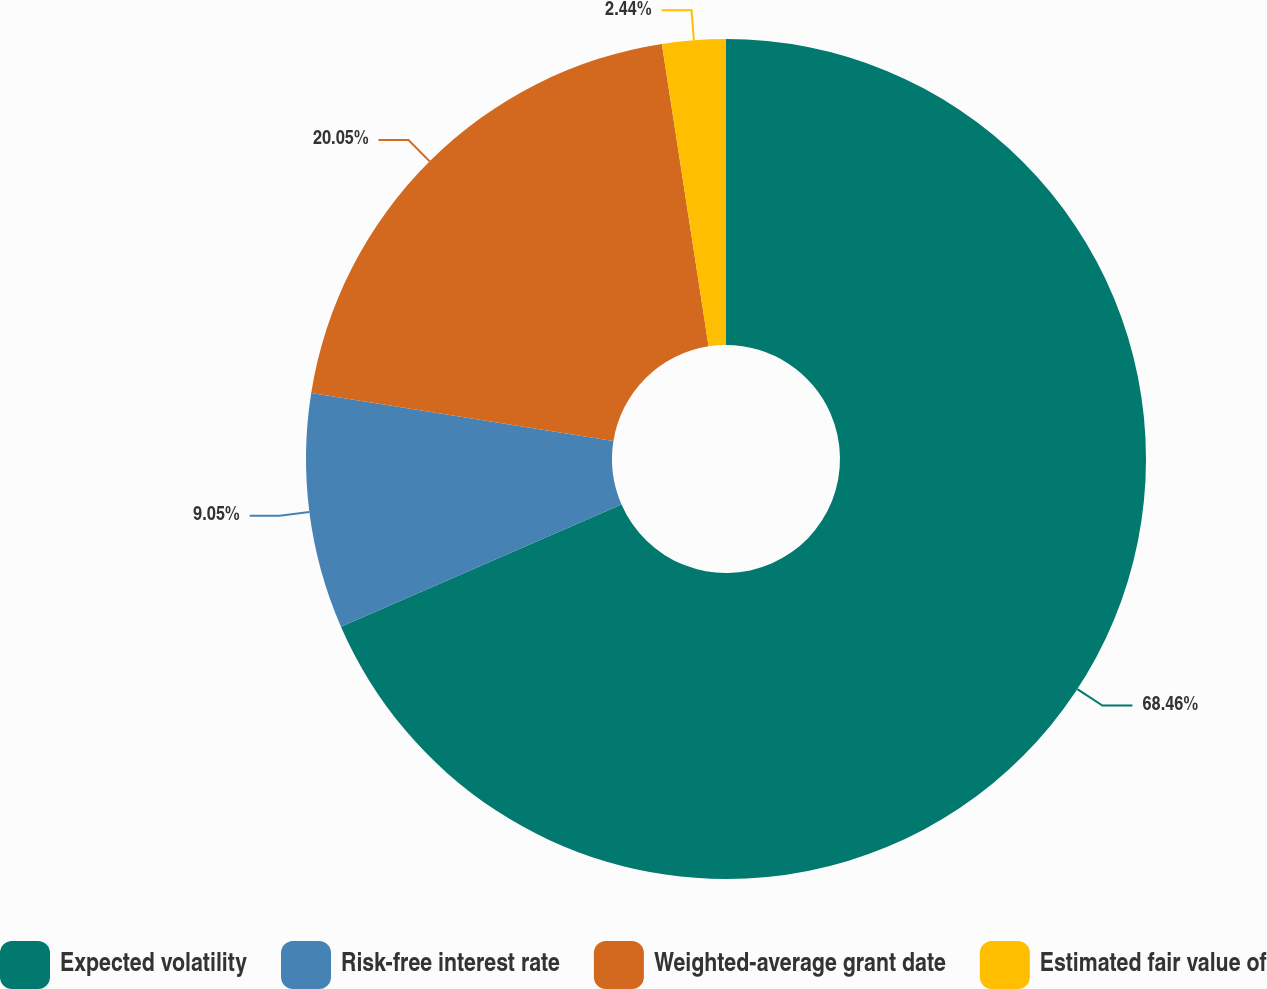Convert chart to OTSL. <chart><loc_0><loc_0><loc_500><loc_500><pie_chart><fcel>Expected volatility<fcel>Risk-free interest rate<fcel>Weighted-average grant date<fcel>Estimated fair value of<nl><fcel>68.46%<fcel>9.05%<fcel>20.05%<fcel>2.44%<nl></chart> 